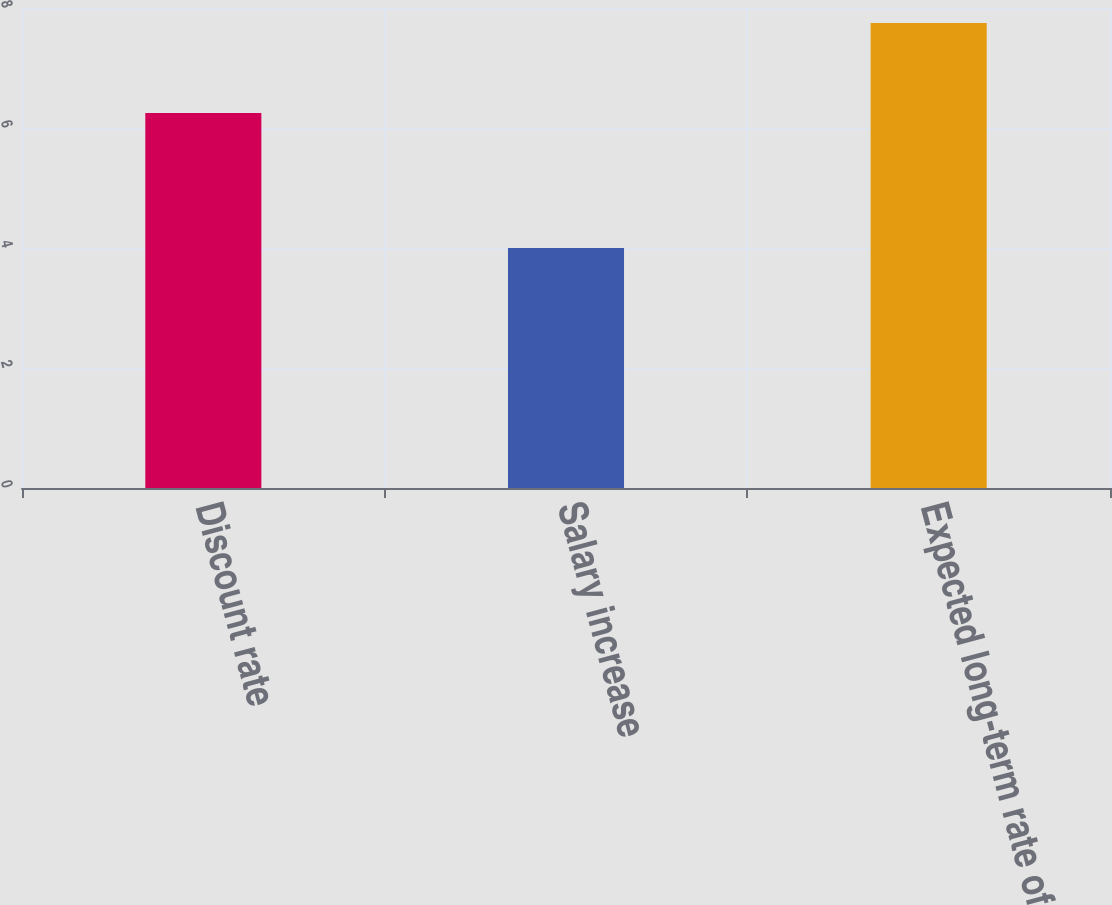Convert chart to OTSL. <chart><loc_0><loc_0><loc_500><loc_500><bar_chart><fcel>Discount rate<fcel>Salary increase<fcel>Expected long-term rate of<nl><fcel>6.25<fcel>4<fcel>7.75<nl></chart> 